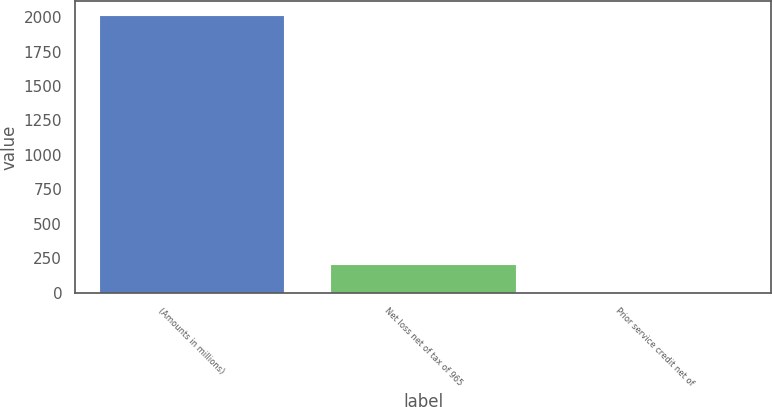<chart> <loc_0><loc_0><loc_500><loc_500><bar_chart><fcel>(Amounts in millions)<fcel>Net loss net of tax of 965<fcel>Prior service credit net of<nl><fcel>2013<fcel>204.9<fcel>4<nl></chart> 